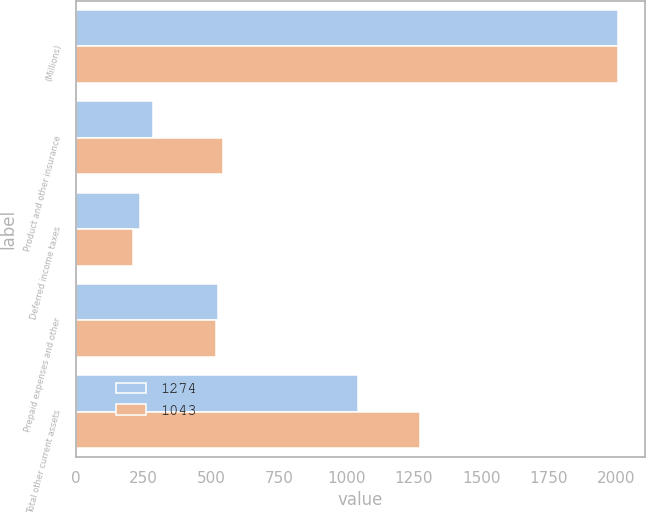<chart> <loc_0><loc_0><loc_500><loc_500><stacked_bar_chart><ecel><fcel>(Millions)<fcel>Product and other insurance<fcel>Deferred income taxes<fcel>Prepaid expenses and other<fcel>Total other current assets<nl><fcel>1274<fcel>2005<fcel>283<fcel>236<fcel>524<fcel>1043<nl><fcel>1043<fcel>2004<fcel>543<fcel>212<fcel>519<fcel>1274<nl></chart> 